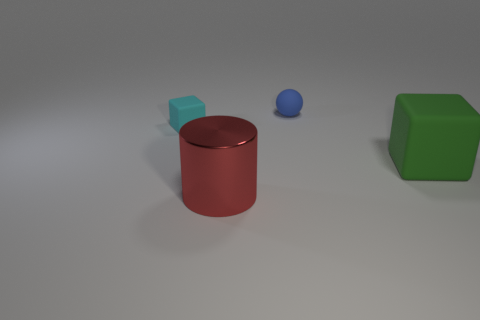Add 2 green rubber cubes. How many objects exist? 6 Subtract all spheres. How many objects are left? 3 Subtract 2 blocks. How many blocks are left? 0 Add 4 large metal cylinders. How many large metal cylinders are left? 5 Add 3 tiny brown metallic cylinders. How many tiny brown metallic cylinders exist? 3 Subtract 1 red cylinders. How many objects are left? 3 Subtract all blue blocks. Subtract all gray spheres. How many blocks are left? 2 Subtract all yellow cubes. How many green spheres are left? 0 Subtract all large green matte things. Subtract all big yellow shiny blocks. How many objects are left? 3 